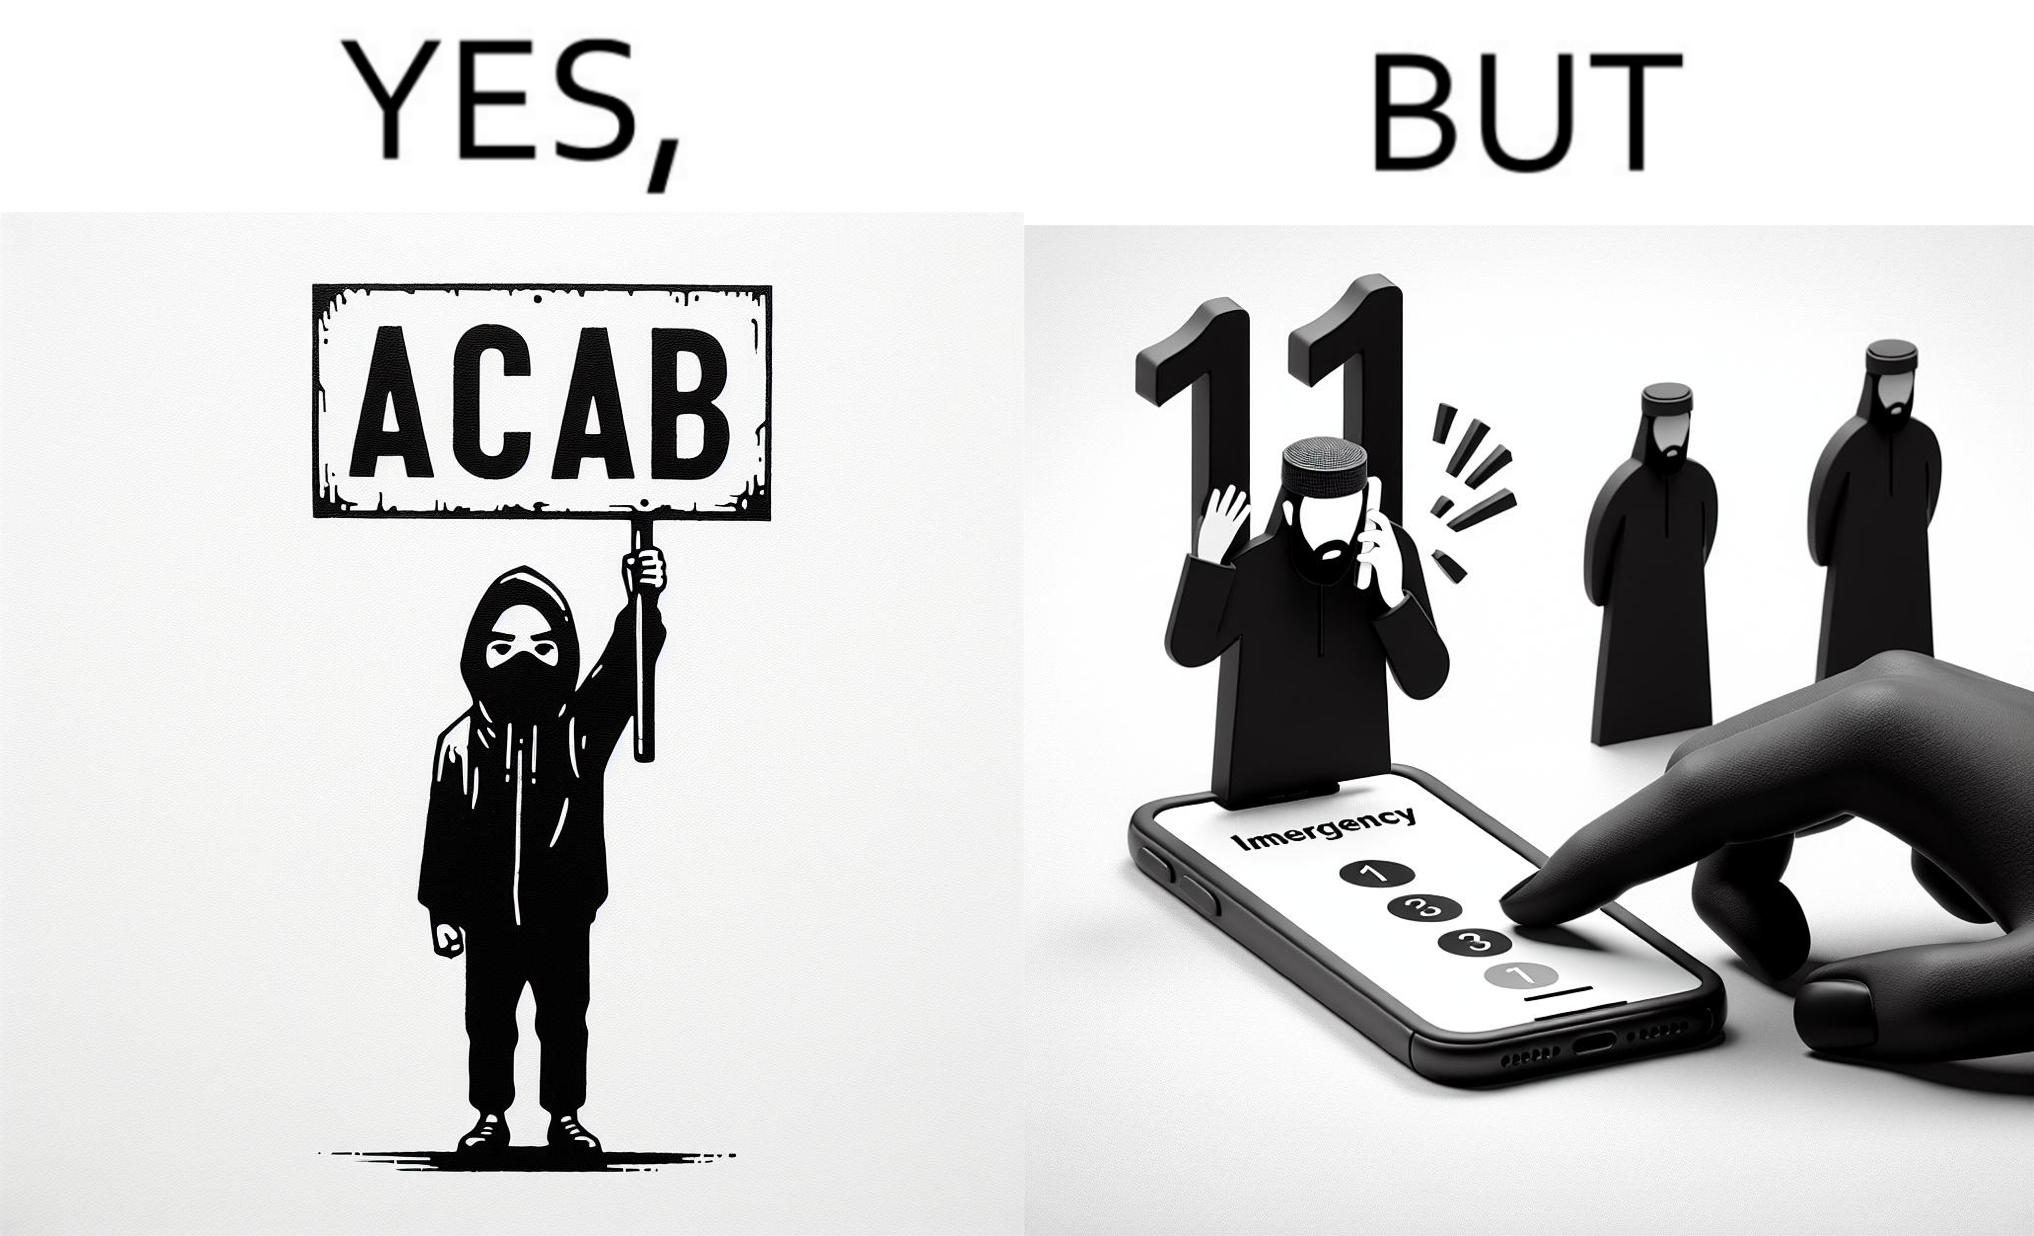Would you classify this image as satirical? Yes, this image is satirical. 